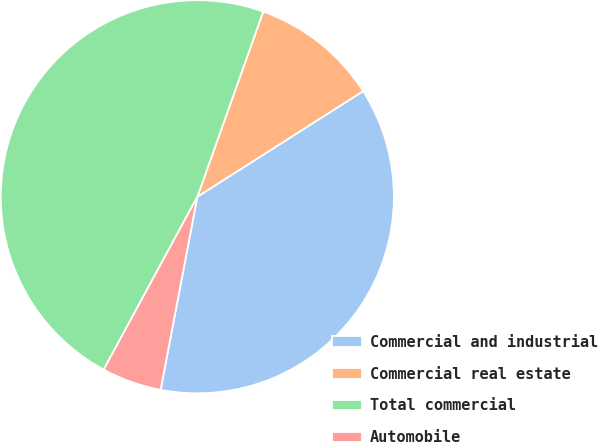<chart> <loc_0><loc_0><loc_500><loc_500><pie_chart><fcel>Commercial and industrial<fcel>Commercial real estate<fcel>Total commercial<fcel>Automobile<nl><fcel>37.02%<fcel>10.53%<fcel>47.54%<fcel>4.91%<nl></chart> 